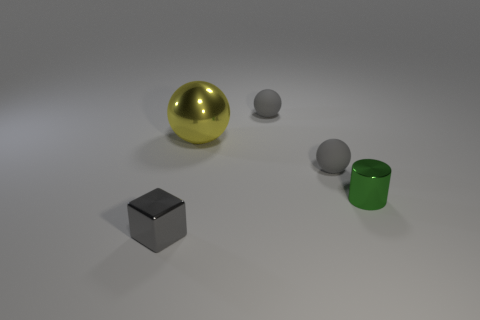Add 4 rubber spheres. How many objects exist? 9 Subtract all blocks. How many objects are left? 4 Subtract all small spheres. Subtract all rubber objects. How many objects are left? 1 Add 4 matte objects. How many matte objects are left? 6 Add 3 blocks. How many blocks exist? 4 Subtract 0 purple blocks. How many objects are left? 5 